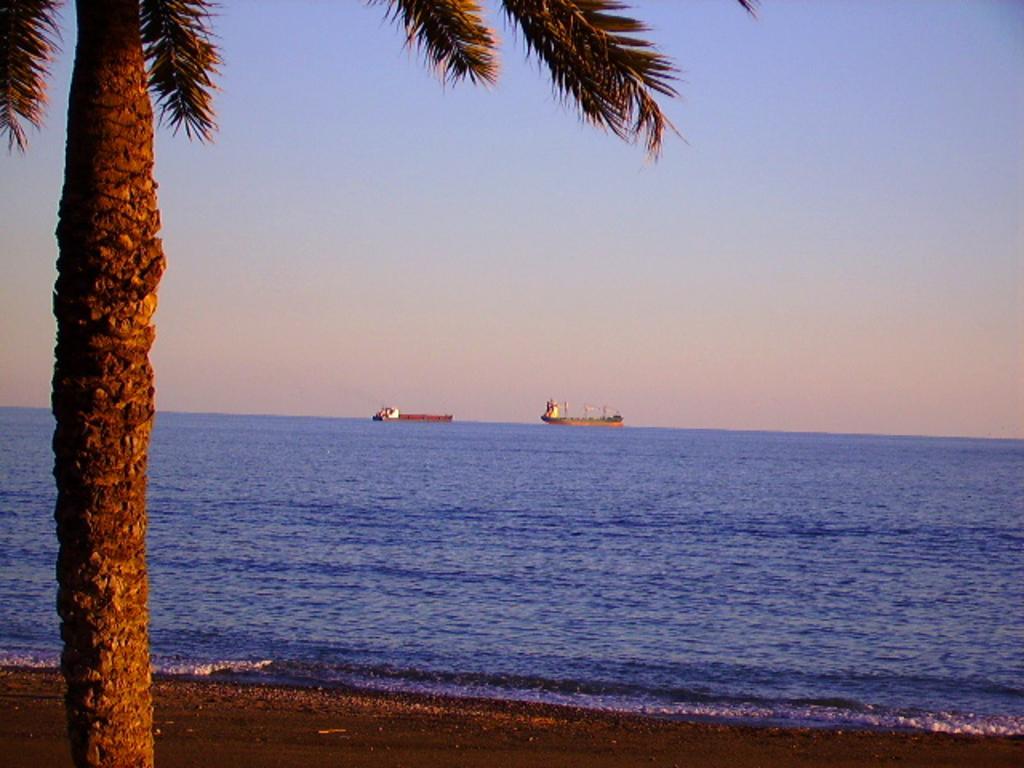How would you summarize this image in a sentence or two? This picture is clicked outside. In the foreground we can see the tree and we can see the ground. In the center we can see the boat and some other objects in the water body. In the background we can see the sky. 